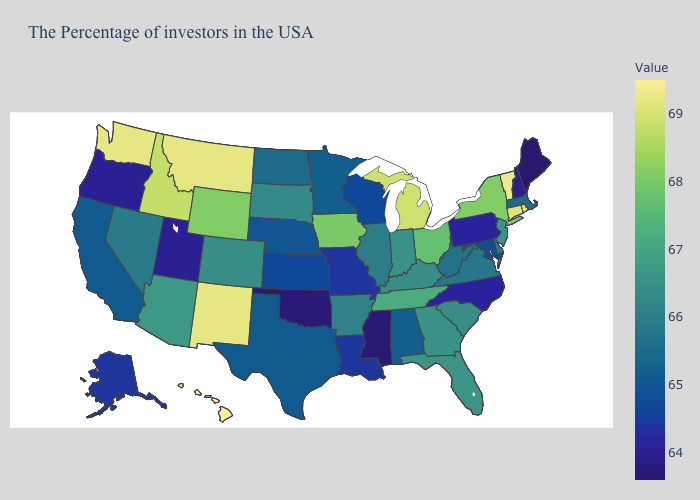Does Nebraska have a higher value than Oklahoma?
Short answer required. Yes. Does Washington have a lower value than Virginia?
Quick response, please. No. Among the states that border Oregon , does Washington have the highest value?
Concise answer only. Yes. Does the map have missing data?
Answer briefly. No. Among the states that border Alabama , does Mississippi have the lowest value?
Answer briefly. Yes. 